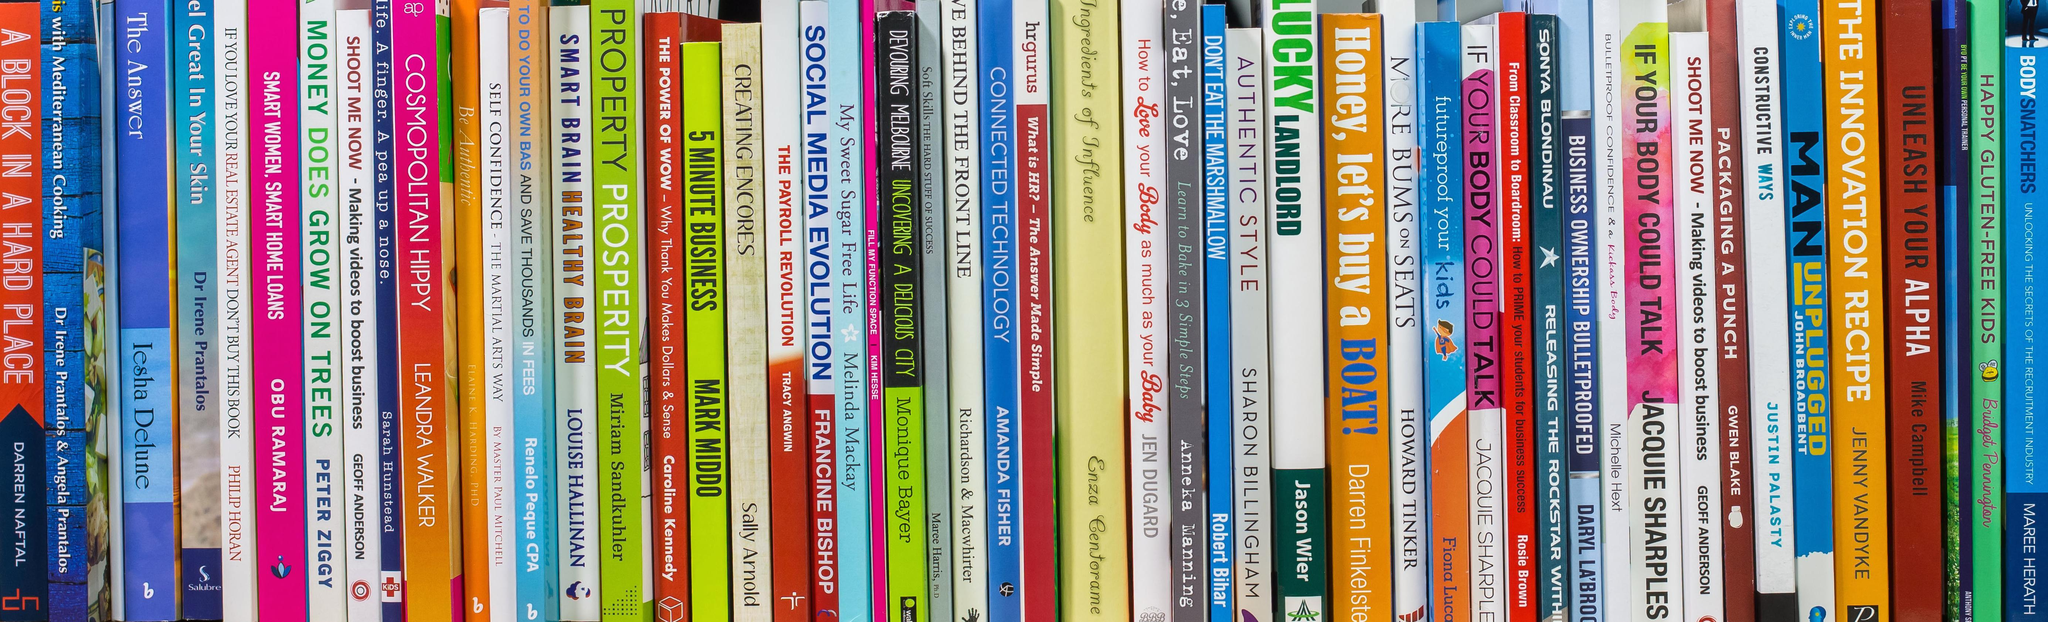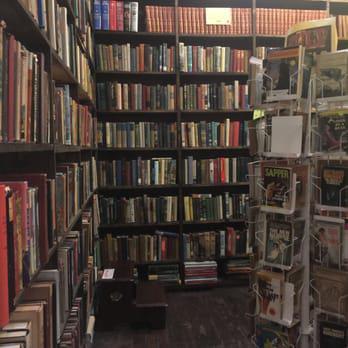The first image is the image on the left, the second image is the image on the right. Analyze the images presented: Is the assertion "There are at least 13 books that are red, blue or white sitting on a single unseen shelve." valid? Answer yes or no. Yes. The first image is the image on the left, the second image is the image on the right. Assess this claim about the two images: "One image shows the spines of books lined upright in a row, and the other image shows books stacked mostly upright on shelves, with some books stacked on their sides.". Correct or not? Answer yes or no. Yes. 